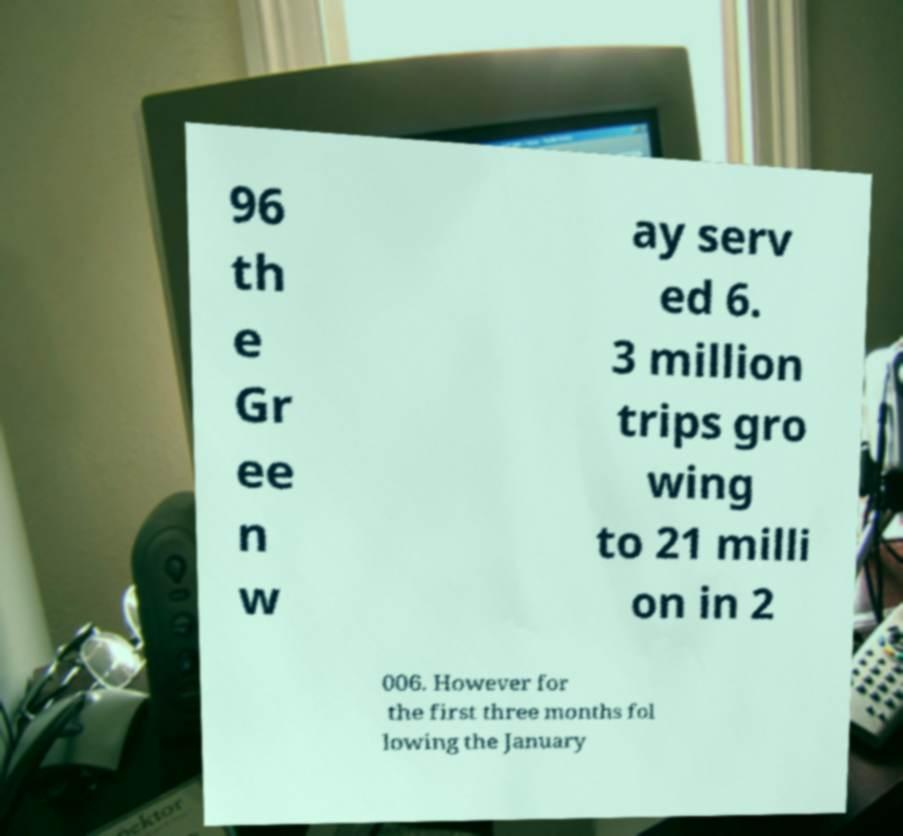What messages or text are displayed in this image? I need them in a readable, typed format. 96 th e Gr ee n w ay serv ed 6. 3 million trips gro wing to 21 milli on in 2 006. However for the first three months fol lowing the January 